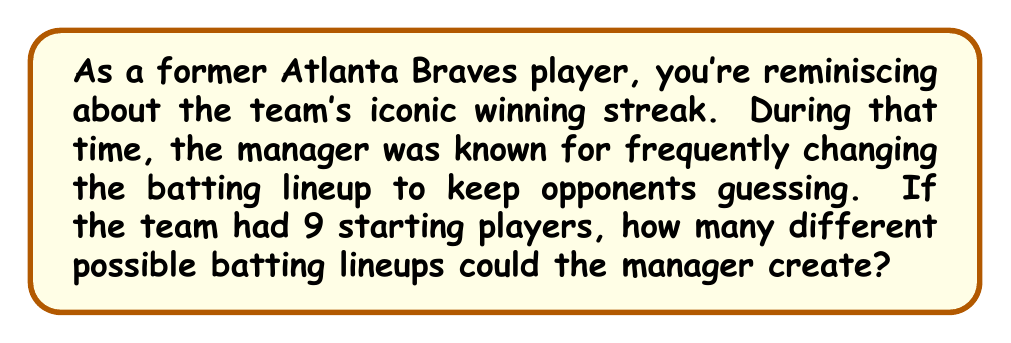Show me your answer to this math problem. To solve this problem, we need to use the concept of permutations from abstract algebra. Here's a step-by-step explanation:

1) In a baseball lineup, the order of the players matters, and each player can only be used once in the lineup. This scenario perfectly fits the definition of a permutation.

2) We are arranging all 9 players in the lineup, so this is a permutation of 9 elements.

3) The number of permutations of $n$ distinct objects is given by $n!$ (n factorial).

4) In this case, $n = 9$, so we need to calculate $9!$

5) Let's expand this:

   $$9! = 9 \times 8 \times 7 \times 6 \times 5 \times 4 \times 3 \times 2 \times 1$$

6) Multiplying these numbers:

   $$9! = 362,880$$

Therefore, the manager could create 362,880 different batting lineups with 9 starting players.

This large number illustrates why changing the batting order could indeed keep opponents guessing, as there were so many possible variations to consider.
Answer: $362,880$ 